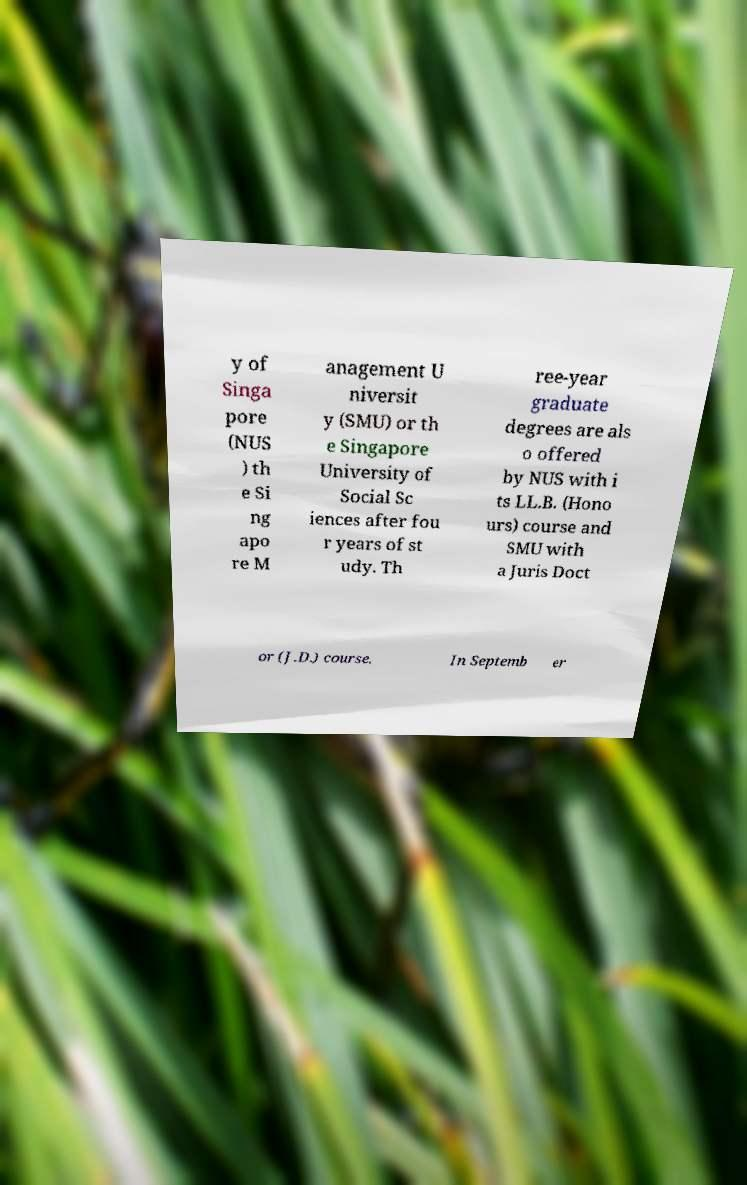I need the written content from this picture converted into text. Can you do that? y of Singa pore (NUS ) th e Si ng apo re M anagement U niversit y (SMU) or th e Singapore University of Social Sc iences after fou r years of st udy. Th ree-year graduate degrees are als o offered by NUS with i ts LL.B. (Hono urs) course and SMU with a Juris Doct or (J.D.) course. In Septemb er 